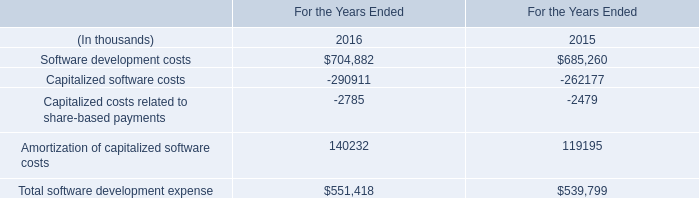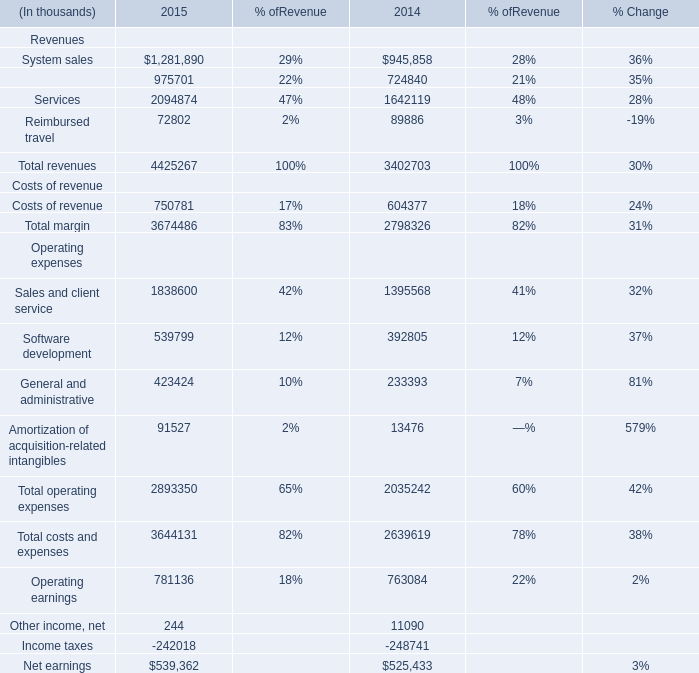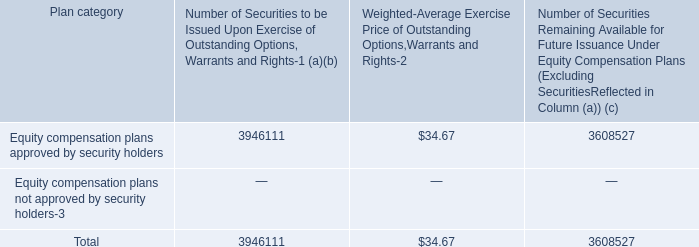what is the total value of issued securities that are approved by security holders , in billions? 
Computations: ((3946111 * 34.67) / 1000000000)
Answer: 0.13681. What's the sum of Sales and client service Operating expenses of 2014, and Software development costs of For the Years Ended 2015 ? 
Computations: (1395568.0 + 685260.0)
Answer: 2080828.0. In which year is Total revenues greater than 4400000 thousand? 
Answer: 2015. 